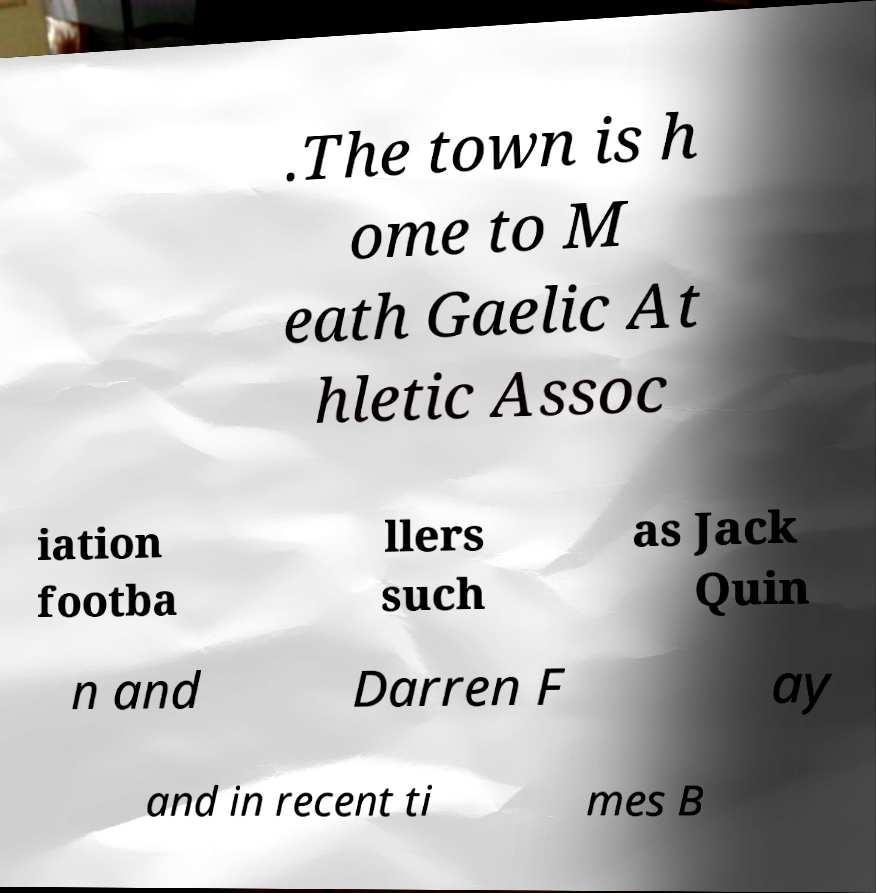What messages or text are displayed in this image? I need them in a readable, typed format. .The town is h ome to M eath Gaelic At hletic Assoc iation footba llers such as Jack Quin n and Darren F ay and in recent ti mes B 